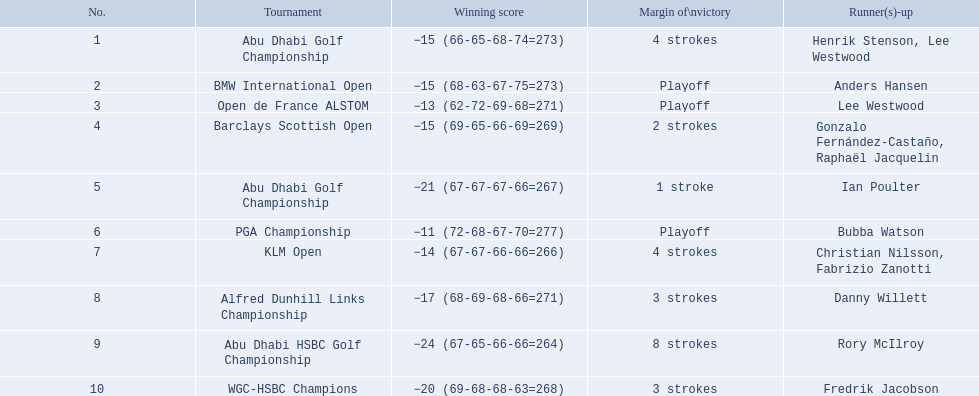What are all of the tournaments? Abu Dhabi Golf Championship, BMW International Open, Open de France ALSTOM, Barclays Scottish Open, Abu Dhabi Golf Championship, PGA Championship, KLM Open, Alfred Dunhill Links Championship, Abu Dhabi HSBC Golf Championship, WGC-HSBC Champions. What was the score during each? −15 (66-65-68-74=273), −15 (68-63-67-75=273), −13 (62-72-69-68=271), −15 (69-65-66-69=269), −21 (67-67-67-66=267), −11 (72-68-67-70=277), −14 (67-67-66-66=266), −17 (68-69-68-66=271), −24 (67-65-66-66=264), −20 (69-68-68-63=268). And who was the runner-up in each? Henrik Stenson, Lee Westwood, Anders Hansen, Lee Westwood, Gonzalo Fernández-Castaño, Raphaël Jacquelin, Ian Poulter, Bubba Watson, Christian Nilsson, Fabrizio Zanotti, Danny Willett, Rory McIlroy, Fredrik Jacobson. What about just during pga games? Bubba Watson. 